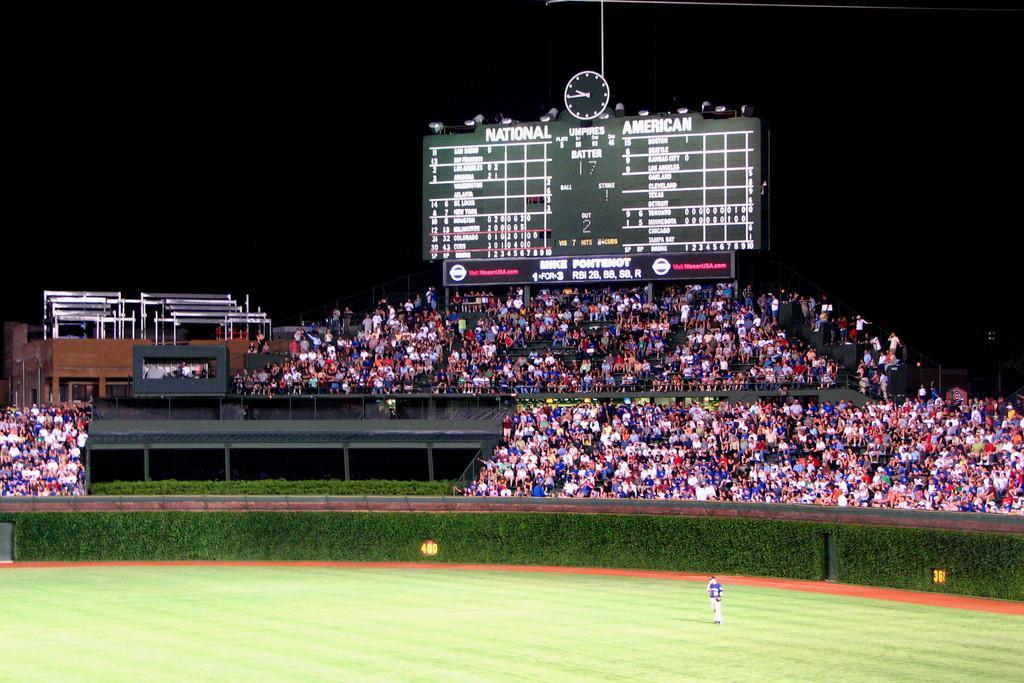Describe this image in one or two sentences. This image is clicked in a stadium. At the bottom, there is green grass on the ground. And there is a person standing on the ground. In the background, there is a huge crowd along with a scoreboard. At the top, the background is too dark. 